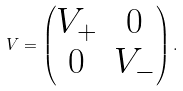<formula> <loc_0><loc_0><loc_500><loc_500>V = \begin{pmatrix} V _ { + } & 0 \\ 0 & V _ { - } \end{pmatrix} .</formula> 